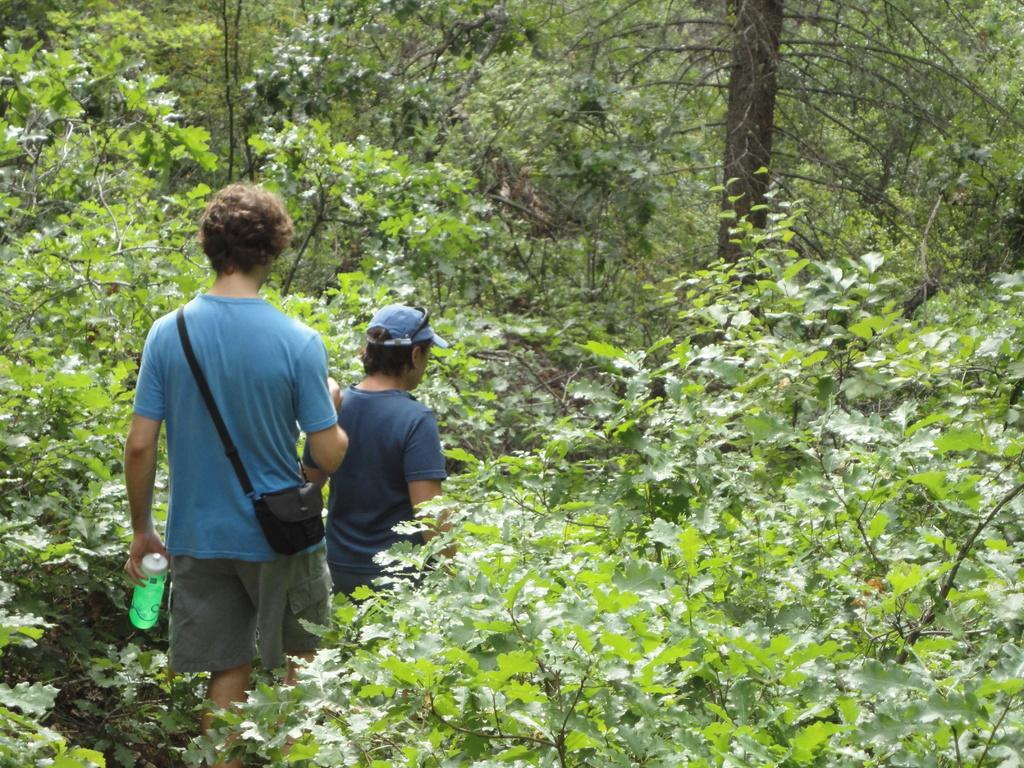How many people are in the image? There are two people in the image. What are the people doing in the image? The two people are walking on a path. What is one of the people holding? One of the people is holding a bottle. What is the other person carrying? The other person is carrying a bag on his shoulder. What can be seen in the background around the people? There are trees around the people. What language are the people speaking in the image? The image does not provide any information about the language being spoken by the people. What is the tax rate in the area where the people are walking? The image does not provide any information about the tax rate in the area. 